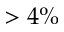<formula> <loc_0><loc_0><loc_500><loc_500>> 4 \%</formula> 